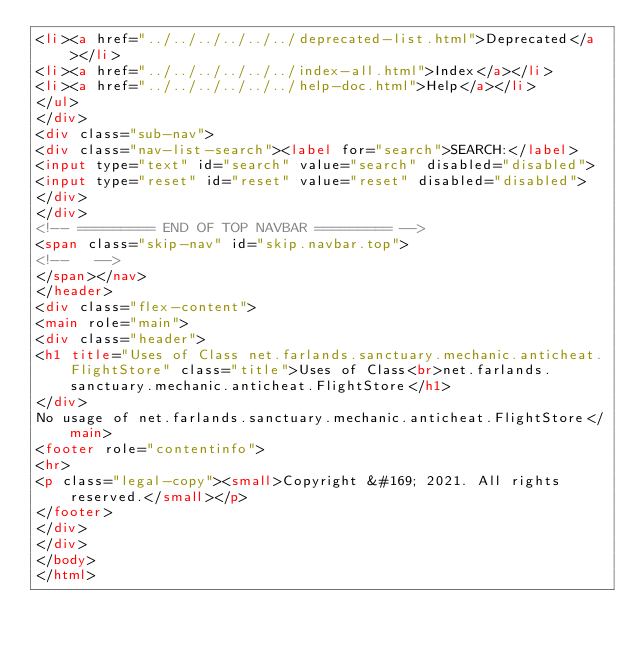<code> <loc_0><loc_0><loc_500><loc_500><_HTML_><li><a href="../../../../../../deprecated-list.html">Deprecated</a></li>
<li><a href="../../../../../../index-all.html">Index</a></li>
<li><a href="../../../../../../help-doc.html">Help</a></li>
</ul>
</div>
<div class="sub-nav">
<div class="nav-list-search"><label for="search">SEARCH:</label>
<input type="text" id="search" value="search" disabled="disabled">
<input type="reset" id="reset" value="reset" disabled="disabled">
</div>
</div>
<!-- ========= END OF TOP NAVBAR ========= -->
<span class="skip-nav" id="skip.navbar.top">
<!--   -->
</span></nav>
</header>
<div class="flex-content">
<main role="main">
<div class="header">
<h1 title="Uses of Class net.farlands.sanctuary.mechanic.anticheat.FlightStore" class="title">Uses of Class<br>net.farlands.sanctuary.mechanic.anticheat.FlightStore</h1>
</div>
No usage of net.farlands.sanctuary.mechanic.anticheat.FlightStore</main>
<footer role="contentinfo">
<hr>
<p class="legal-copy"><small>Copyright &#169; 2021. All rights reserved.</small></p>
</footer>
</div>
</div>
</body>
</html>
</code> 